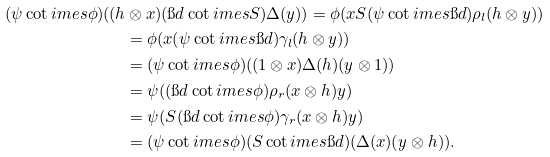Convert formula to latex. <formula><loc_0><loc_0><loc_500><loc_500>( \psi \cot i m e s \phi ) ( ( h & \otimes x ) ( \i d \cot i m e s S ) \Delta ( y ) ) = \phi ( x S ( \psi \cot i m e s \i d ) \rho _ { l } ( h \otimes y ) ) \\ & = \phi ( x ( \psi \cot i m e s \i d ) \gamma _ { l } ( h \otimes y ) ) \\ & = ( \psi \cot i m e s \phi ) ( ( 1 \otimes x ) \Delta ( h ) ( y \otimes 1 ) ) \\ & = \psi ( ( \i d \cot i m e s \phi ) \rho _ { r } ( x \otimes h ) y ) \\ & = \psi ( S ( \i d \cot i m e s \phi ) \gamma _ { r } ( x \otimes h ) y ) \\ & = ( \psi \cot i m e s \phi ) ( S \cot i m e s \i d ) ( \Delta ( x ) ( y \otimes h ) ) .</formula> 